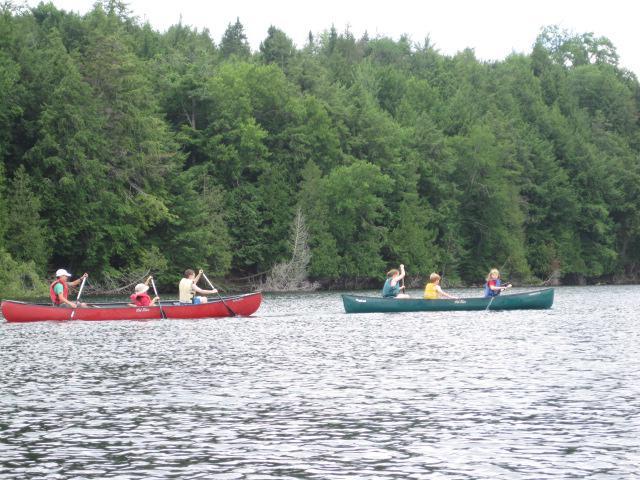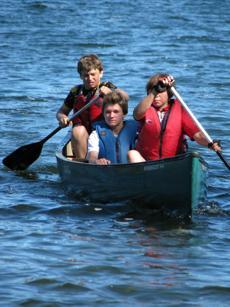The first image is the image on the left, the second image is the image on the right. Examine the images to the left and right. Is the description "There is exactly one boat in the image on the right." accurate? Answer yes or no. Yes. 